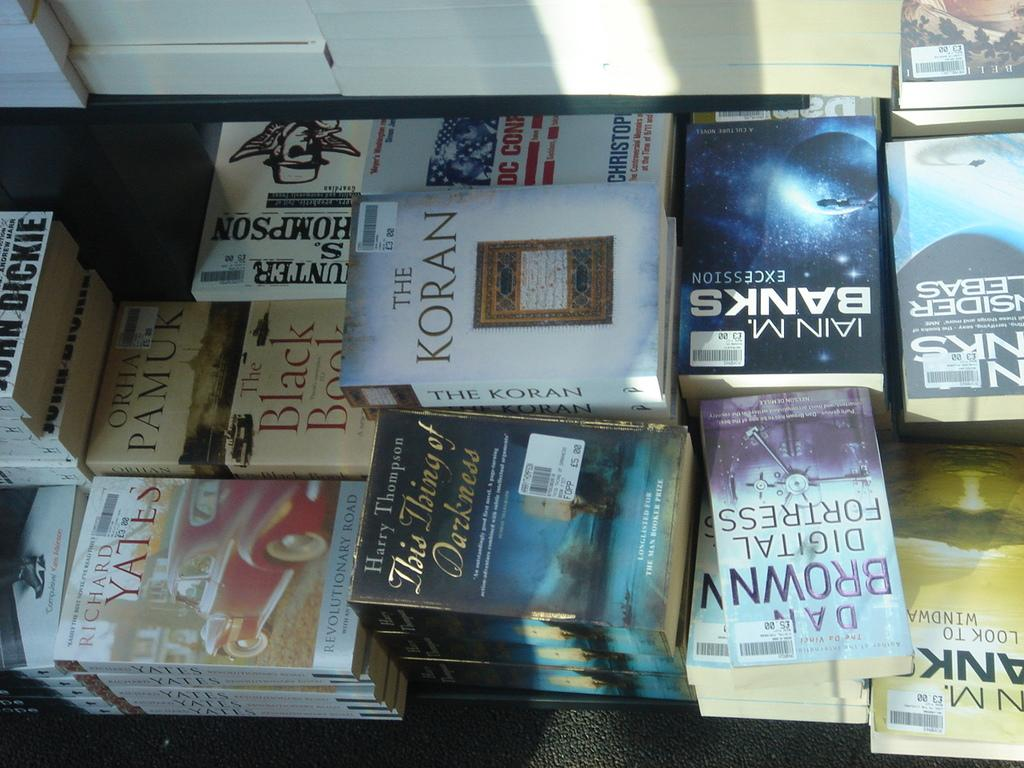<image>
Provide a brief description of the given image. Copies of The Koran are stacked up on a table with many other books. 